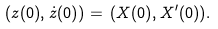<formula> <loc_0><loc_0><loc_500><loc_500>( z ( 0 ) , \dot { z } ( 0 ) ) = \, ( X ( 0 ) , { X } ^ { \prime } ( 0 ) ) .</formula> 